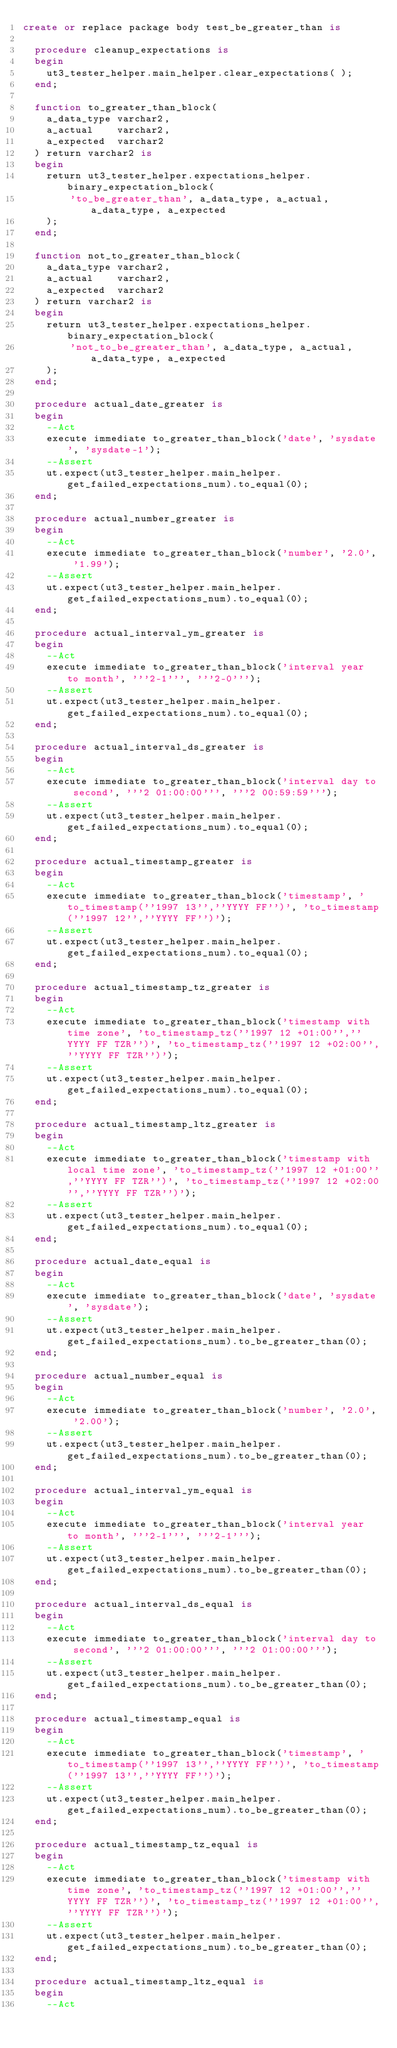Convert code to text. <code><loc_0><loc_0><loc_500><loc_500><_SQL_>create or replace package body test_be_greater_than is

  procedure cleanup_expectations is
  begin
    ut3_tester_helper.main_helper.clear_expectations( );
  end;

  function to_greater_than_block(
    a_data_type varchar2,
    a_actual    varchar2,
    a_expected  varchar2
  ) return varchar2 is
  begin
    return ut3_tester_helper.expectations_helper.binary_expectation_block(
        'to_be_greater_than', a_data_type, a_actual, a_data_type, a_expected
    );
  end;

  function not_to_greater_than_block(
    a_data_type varchar2,
    a_actual    varchar2,
    a_expected  varchar2
  ) return varchar2 is
  begin
    return ut3_tester_helper.expectations_helper.binary_expectation_block(
        'not_to_be_greater_than', a_data_type, a_actual, a_data_type, a_expected
    );
  end;

  procedure actual_date_greater is
  begin
    --Act
    execute immediate to_greater_than_block('date', 'sysdate', 'sysdate-1');
    --Assert
    ut.expect(ut3_tester_helper.main_helper.get_failed_expectations_num).to_equal(0);
  end;

  procedure actual_number_greater is
  begin
    --Act
    execute immediate to_greater_than_block('number', '2.0', '1.99');
    --Assert
    ut.expect(ut3_tester_helper.main_helper.get_failed_expectations_num).to_equal(0);
  end;

  procedure actual_interval_ym_greater is
  begin
    --Act
    execute immediate to_greater_than_block('interval year to month', '''2-1''', '''2-0''');
    --Assert
    ut.expect(ut3_tester_helper.main_helper.get_failed_expectations_num).to_equal(0);
  end;

  procedure actual_interval_ds_greater is
  begin
    --Act
    execute immediate to_greater_than_block('interval day to second', '''2 01:00:00''', '''2 00:59:59''');
    --Assert
    ut.expect(ut3_tester_helper.main_helper.get_failed_expectations_num).to_equal(0);
  end;

  procedure actual_timestamp_greater is
  begin
    --Act
    execute immediate to_greater_than_block('timestamp', 'to_timestamp(''1997 13'',''YYYY FF'')', 'to_timestamp(''1997 12'',''YYYY FF'')');
    --Assert
    ut.expect(ut3_tester_helper.main_helper.get_failed_expectations_num).to_equal(0);
  end;

  procedure actual_timestamp_tz_greater is
  begin
    --Act
    execute immediate to_greater_than_block('timestamp with time zone', 'to_timestamp_tz(''1997 12 +01:00'',''YYYY FF TZR'')', 'to_timestamp_tz(''1997 12 +02:00'',''YYYY FF TZR'')');
    --Assert
    ut.expect(ut3_tester_helper.main_helper.get_failed_expectations_num).to_equal(0);
  end;

  procedure actual_timestamp_ltz_greater is
  begin
    --Act
    execute immediate to_greater_than_block('timestamp with local time zone', 'to_timestamp_tz(''1997 12 +01:00'',''YYYY FF TZR'')', 'to_timestamp_tz(''1997 12 +02:00'',''YYYY FF TZR'')');
    --Assert
    ut.expect(ut3_tester_helper.main_helper.get_failed_expectations_num).to_equal(0);
  end;

  procedure actual_date_equal is
  begin
    --Act
    execute immediate to_greater_than_block('date', 'sysdate', 'sysdate');
    --Assert
    ut.expect(ut3_tester_helper.main_helper.get_failed_expectations_num).to_be_greater_than(0);
  end;

  procedure actual_number_equal is
  begin
    --Act
    execute immediate to_greater_than_block('number', '2.0', '2.00');
    --Assert
    ut.expect(ut3_tester_helper.main_helper.get_failed_expectations_num).to_be_greater_than(0);
  end;

  procedure actual_interval_ym_equal is
  begin
    --Act
    execute immediate to_greater_than_block('interval year to month', '''2-1''', '''2-1''');
    --Assert
    ut.expect(ut3_tester_helper.main_helper.get_failed_expectations_num).to_be_greater_than(0);
  end;

  procedure actual_interval_ds_equal is
  begin
    --Act
    execute immediate to_greater_than_block('interval day to second', '''2 01:00:00''', '''2 01:00:00''');
    --Assert
    ut.expect(ut3_tester_helper.main_helper.get_failed_expectations_num).to_be_greater_than(0);
  end;

  procedure actual_timestamp_equal is
  begin
    --Act
    execute immediate to_greater_than_block('timestamp', 'to_timestamp(''1997 13'',''YYYY FF'')', 'to_timestamp(''1997 13'',''YYYY FF'')');
    --Assert
    ut.expect(ut3_tester_helper.main_helper.get_failed_expectations_num).to_be_greater_than(0);
  end;

  procedure actual_timestamp_tz_equal is
  begin
    --Act
    execute immediate to_greater_than_block('timestamp with time zone', 'to_timestamp_tz(''1997 12 +01:00'',''YYYY FF TZR'')', 'to_timestamp_tz(''1997 12 +01:00'',''YYYY FF TZR'')');
    --Assert
    ut.expect(ut3_tester_helper.main_helper.get_failed_expectations_num).to_be_greater_than(0);
  end;

  procedure actual_timestamp_ltz_equal is
  begin
    --Act</code> 